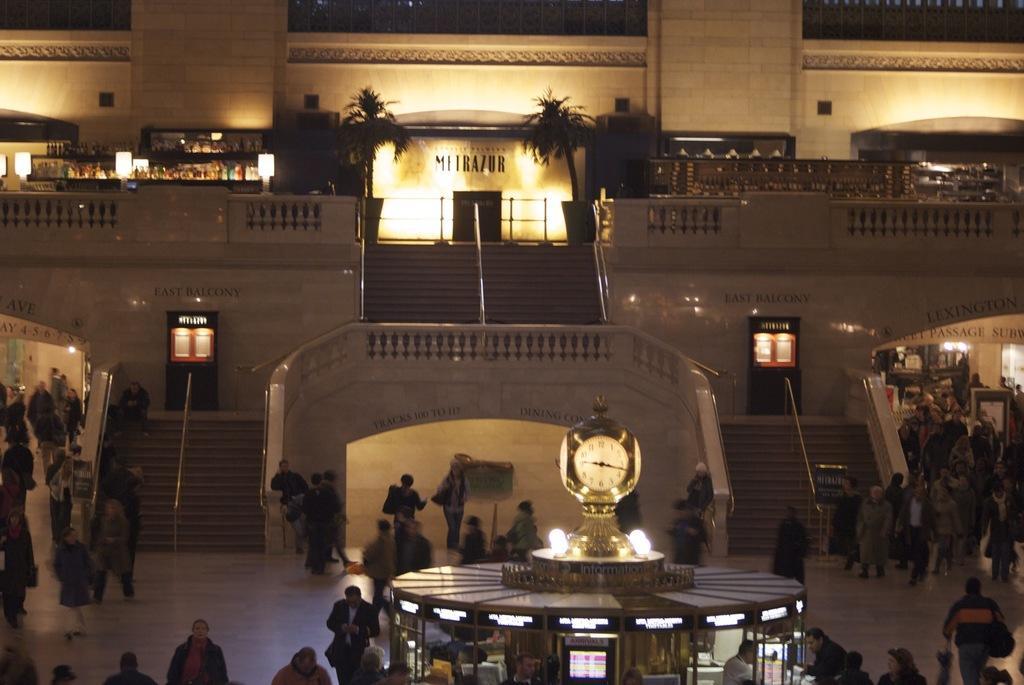In one or two sentences, can you explain what this image depicts? In this image there are a group of people some of them are standing and some of them are walking, and in the foreground there is one clock and house. In the background there is a building, trees stairs, lights and doors. 